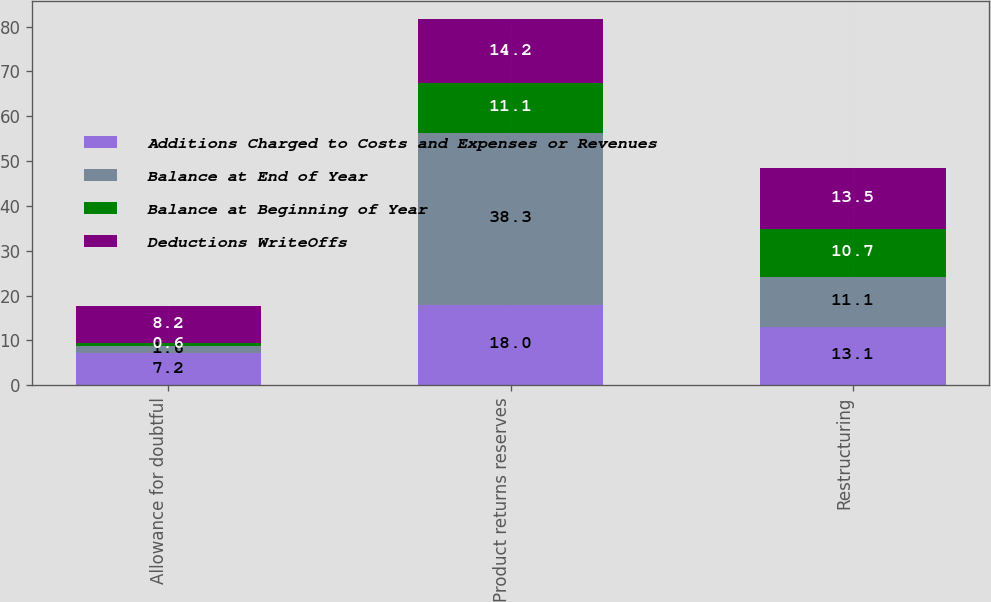<chart> <loc_0><loc_0><loc_500><loc_500><stacked_bar_chart><ecel><fcel>Allowance for doubtful<fcel>Product returns reserves<fcel>Restructuring<nl><fcel>Additions Charged to Costs and Expenses or Revenues<fcel>7.2<fcel>18<fcel>13.1<nl><fcel>Balance at End of Year<fcel>1.6<fcel>38.3<fcel>11.1<nl><fcel>Balance at Beginning of Year<fcel>0.6<fcel>11.1<fcel>10.7<nl><fcel>Deductions WriteOffs<fcel>8.2<fcel>14.2<fcel>13.5<nl></chart> 